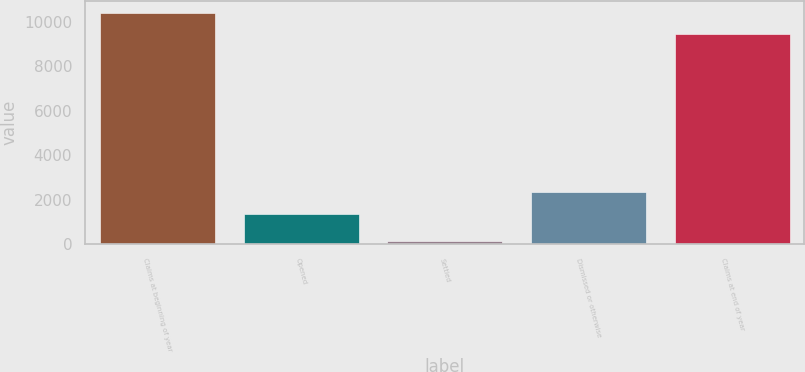<chart> <loc_0><loc_0><loc_500><loc_500><bar_chart><fcel>Claims at beginning of year<fcel>Opened<fcel>Settled<fcel>Dismissed or otherwise<fcel>Claims at end of year<nl><fcel>10413.8<fcel>1383<fcel>155<fcel>2354.8<fcel>9442<nl></chart> 